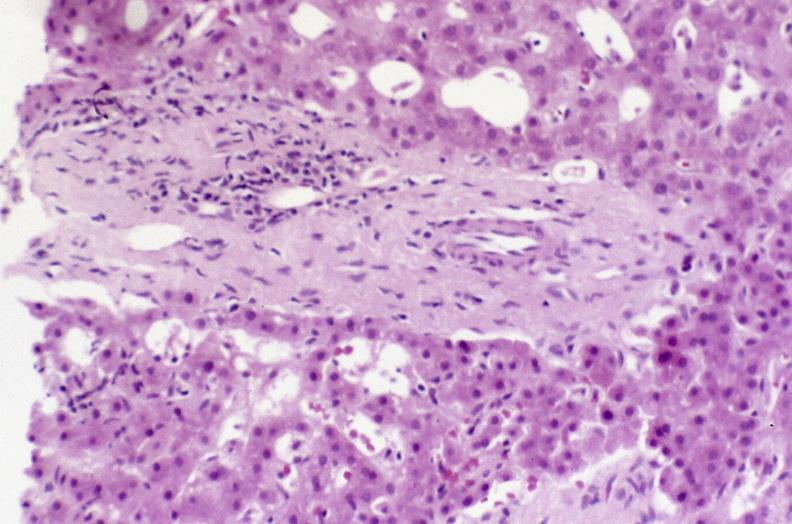does aorta show recovery of ducts?
Answer the question using a single word or phrase. No 